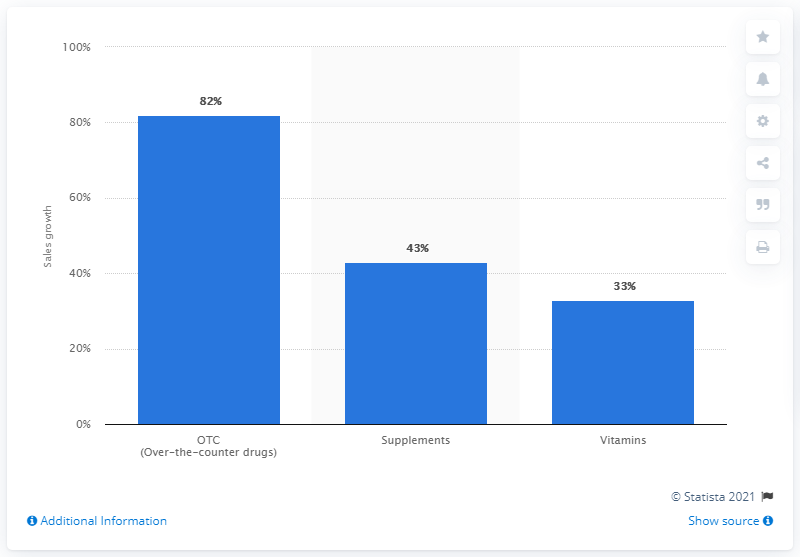Highlight a few significant elements in this photo. The sales of over-the-counter drugs in Colombia increased by 82% in February 2020. The sales of supplements and vitamins in Colombia increased by 82% in the previous year. The sales of over-the-counter drugs in Colombia increased by 82% in February 2020. 